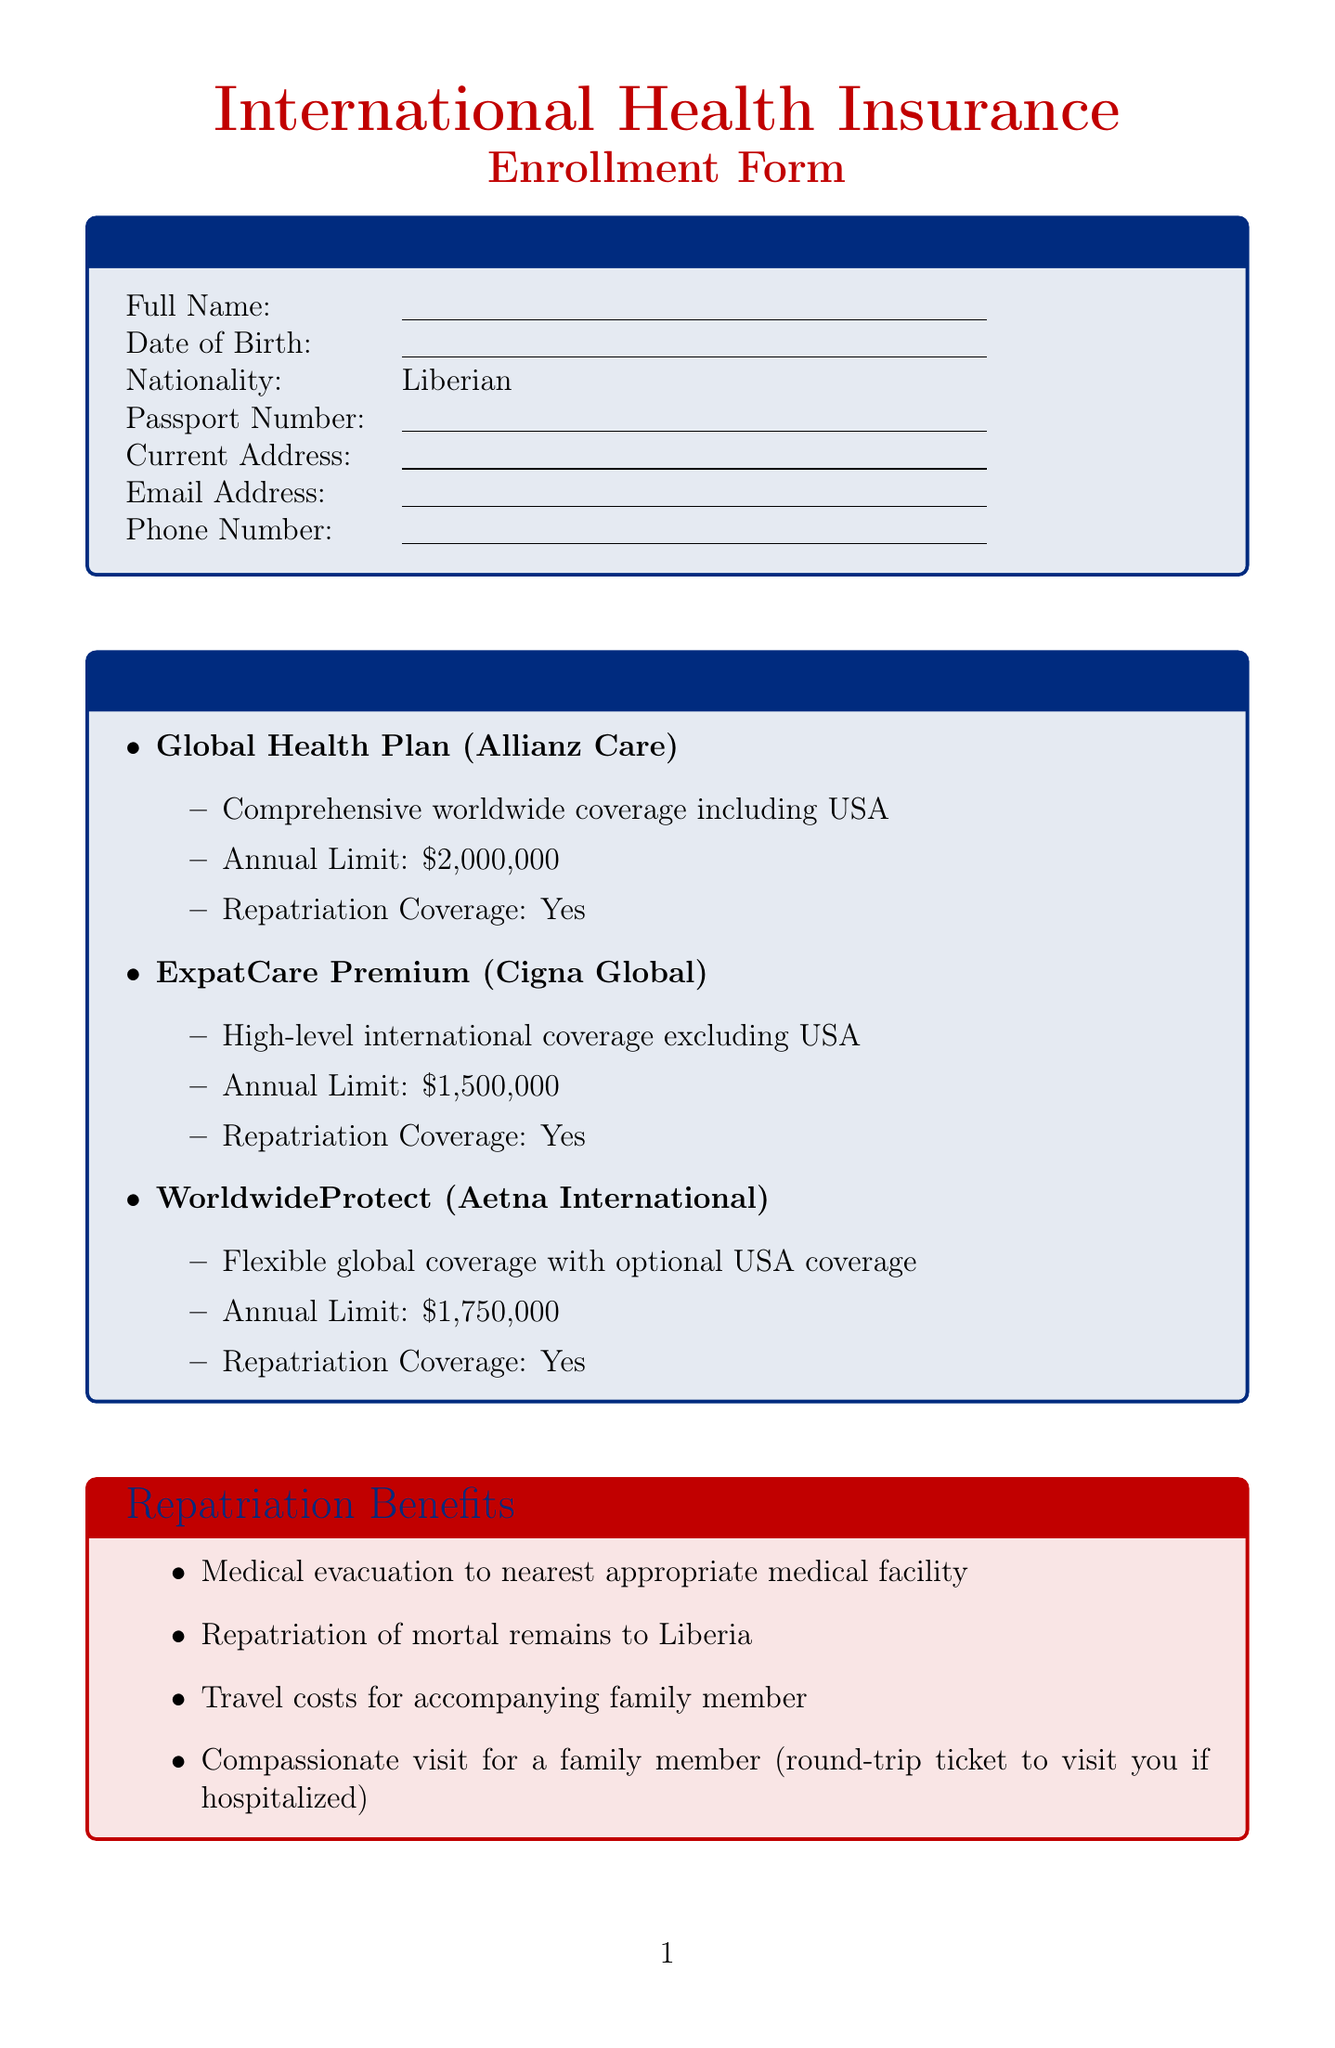What is the title of the form? The title of the form is found at the top of the document.
Answer: International Health Insurance Enrollment Form Who is the provider of the Global Health Plan? The provider of the Global Health Plan is mentioned under the coverage options.
Answer: Allianz Care What is the annual limit for the ExpatCare Premium? The annual limit for the ExpatCare Premium is specified in the document.
Answer: $1,500,000 What repatriation benefit includes travel costs for an accompanying family member? The specific benefit related to accompanying family members is detailed in the repatriation benefits.
Answer: Travel costs for accompanying family member Name one pre-existing condition listed in the document. Several pre-existing conditions are listed in the section of the document dedicated to this topic.
Answer: Malaria What payment option is available if I want to pay annually? Payment options detail various ways to pay, including for an annual choice.
Answer: Annual lump sum How many Liberian healthcare providers are mentioned? The number of healthcare providers can be counted from the section on this topic.
Answer: 3 What is required for the accuracy statement? The accuracy statement is a part of the declaration and specifies what the applicant must declare about the information provided.
Answer: Accurate and complete information Is repatriation coverage included in all coverage options? This question involves checking each coverage option for repatriation coverage.
Answer: Yes 